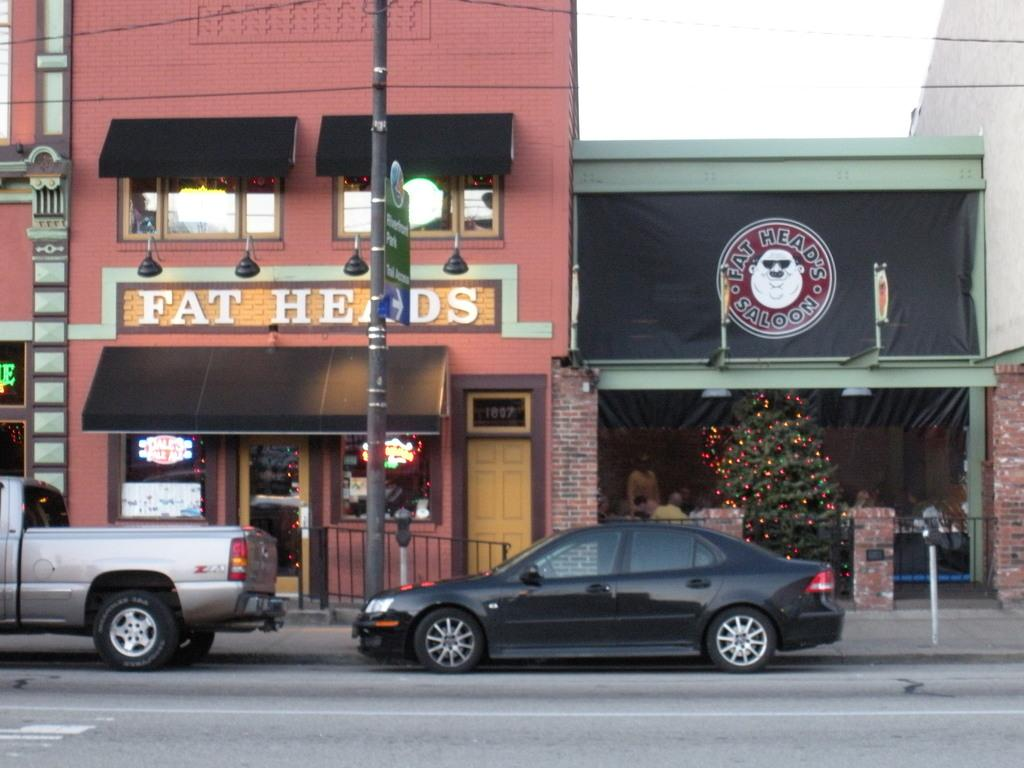<image>
Present a compact description of the photo's key features. The Fat Head's Saloon has a Christmas tree inside. 